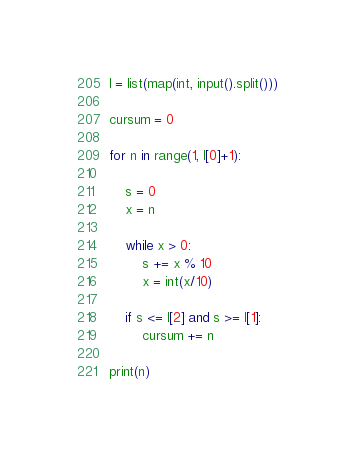<code> <loc_0><loc_0><loc_500><loc_500><_Python_>l = list(map(int, input().split()))

cursum = 0

for n in range(1, l[0]+1):
    
    s = 0
    x = n

    while x > 0:
        s += x % 10
        x = int(x/10)

    if s <= l[2] and s >= l[1]:
        cursum += n

print(n)</code> 